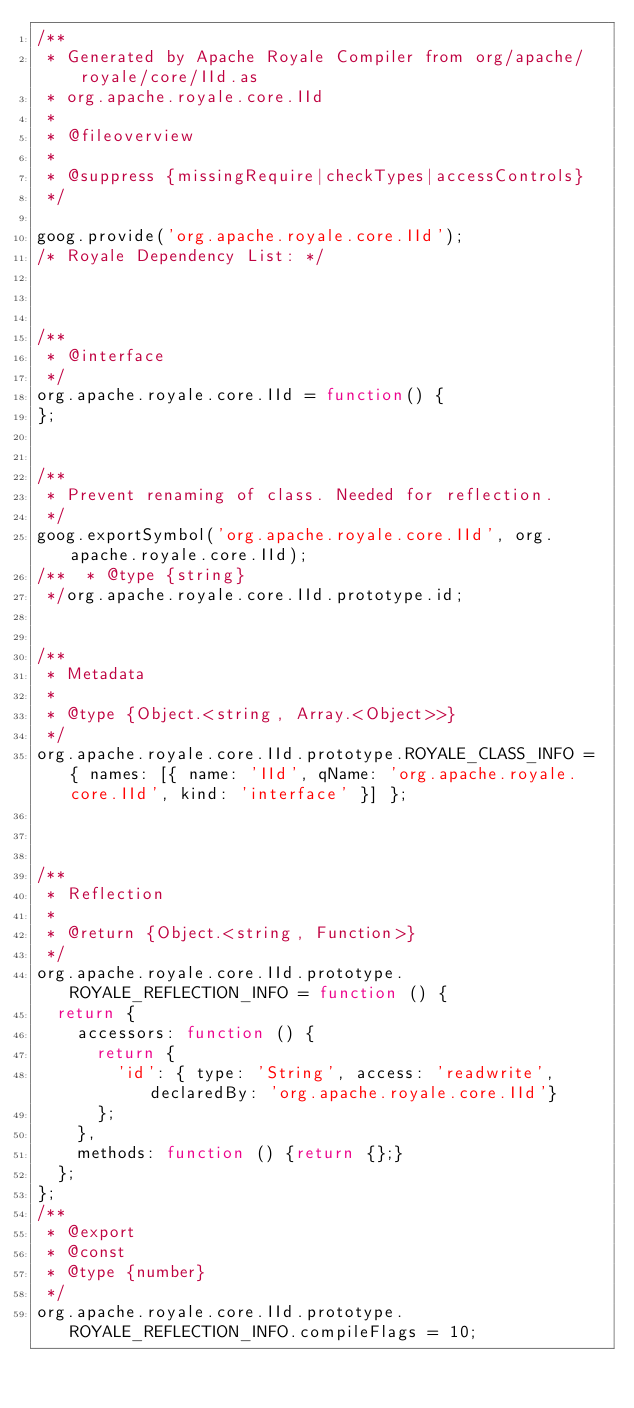Convert code to text. <code><loc_0><loc_0><loc_500><loc_500><_JavaScript_>/**
 * Generated by Apache Royale Compiler from org/apache/royale/core/IId.as
 * org.apache.royale.core.IId
 *
 * @fileoverview
 *
 * @suppress {missingRequire|checkTypes|accessControls}
 */

goog.provide('org.apache.royale.core.IId');
/* Royale Dependency List: */



/**
 * @interface
 */
org.apache.royale.core.IId = function() {
};


/**
 * Prevent renaming of class. Needed for reflection.
 */
goog.exportSymbol('org.apache.royale.core.IId', org.apache.royale.core.IId);
/**  * @type {string}
 */org.apache.royale.core.IId.prototype.id;


/**
 * Metadata
 *
 * @type {Object.<string, Array.<Object>>}
 */
org.apache.royale.core.IId.prototype.ROYALE_CLASS_INFO = { names: [{ name: 'IId', qName: 'org.apache.royale.core.IId', kind: 'interface' }] };



/**
 * Reflection
 *
 * @return {Object.<string, Function>}
 */
org.apache.royale.core.IId.prototype.ROYALE_REFLECTION_INFO = function () {
  return {
    accessors: function () {
      return {
        'id': { type: 'String', access: 'readwrite', declaredBy: 'org.apache.royale.core.IId'}
      };
    },
    methods: function () {return {};}
  };
};
/**
 * @export
 * @const
 * @type {number}
 */
org.apache.royale.core.IId.prototype.ROYALE_REFLECTION_INFO.compileFlags = 10;
</code> 